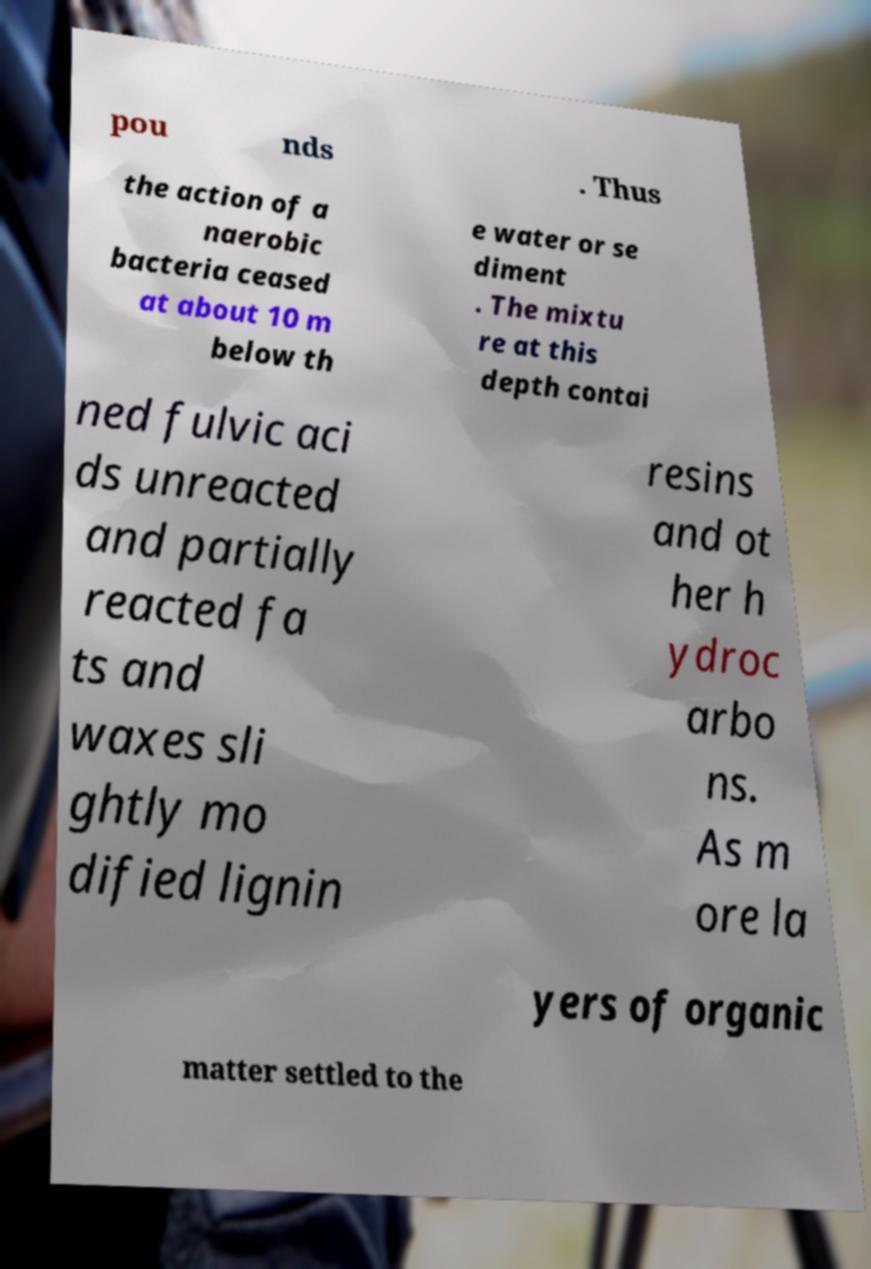I need the written content from this picture converted into text. Can you do that? pou nds . Thus the action of a naerobic bacteria ceased at about 10 m below th e water or se diment . The mixtu re at this depth contai ned fulvic aci ds unreacted and partially reacted fa ts and waxes sli ghtly mo dified lignin resins and ot her h ydroc arbo ns. As m ore la yers of organic matter settled to the 